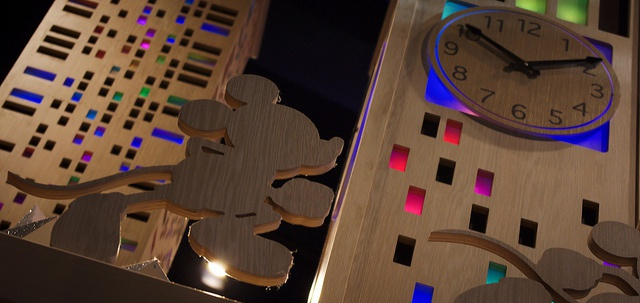Describe the objects in this image and their specific colors. I can see a clock in black, maroon, and purple tones in this image. 